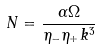<formula> <loc_0><loc_0><loc_500><loc_500>N = \frac { \alpha \Omega } { \eta _ { - } \eta _ { + } k ^ { 3 } }</formula> 